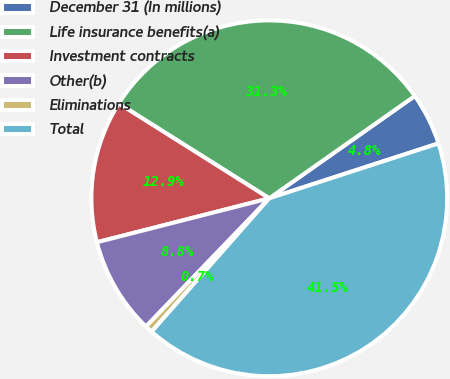Convert chart to OTSL. <chart><loc_0><loc_0><loc_500><loc_500><pie_chart><fcel>December 31 (In millions)<fcel>Life insurance benefits(a)<fcel>Investment contracts<fcel>Other(b)<fcel>Eliminations<fcel>Total<nl><fcel>4.76%<fcel>31.3%<fcel>12.92%<fcel>8.84%<fcel>0.68%<fcel>41.5%<nl></chart> 